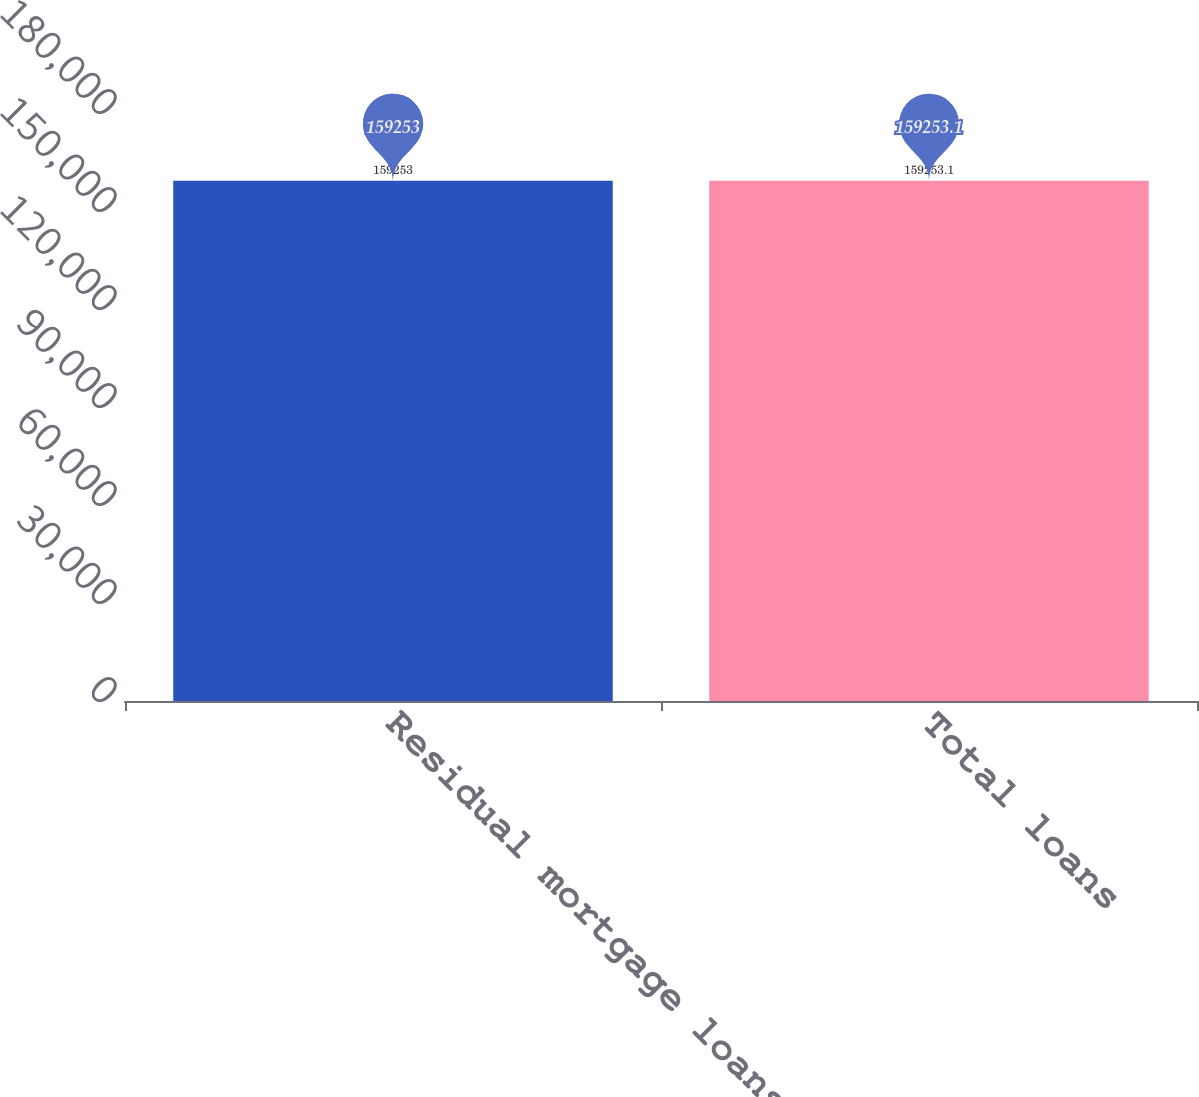<chart> <loc_0><loc_0><loc_500><loc_500><bar_chart><fcel>Residual mortgage loans<fcel>Total loans<nl><fcel>159253<fcel>159253<nl></chart> 